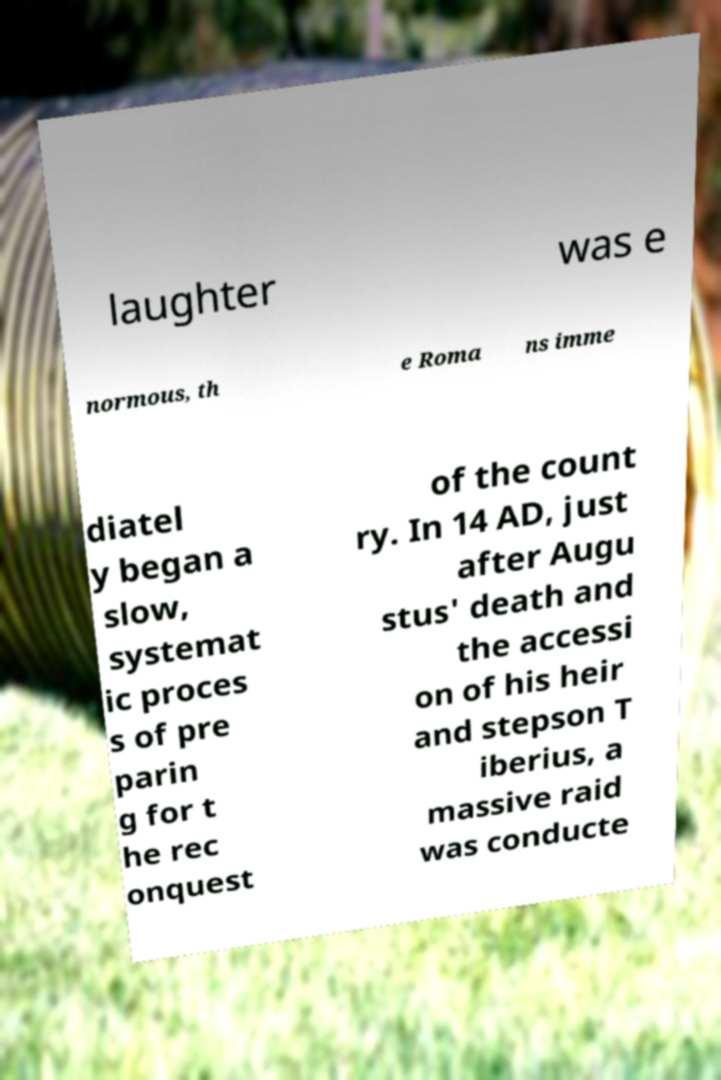Can you read and provide the text displayed in the image?This photo seems to have some interesting text. Can you extract and type it out for me? laughter was e normous, th e Roma ns imme diatel y began a slow, systemat ic proces s of pre parin g for t he rec onquest of the count ry. In 14 AD, just after Augu stus' death and the accessi on of his heir and stepson T iberius, a massive raid was conducte 